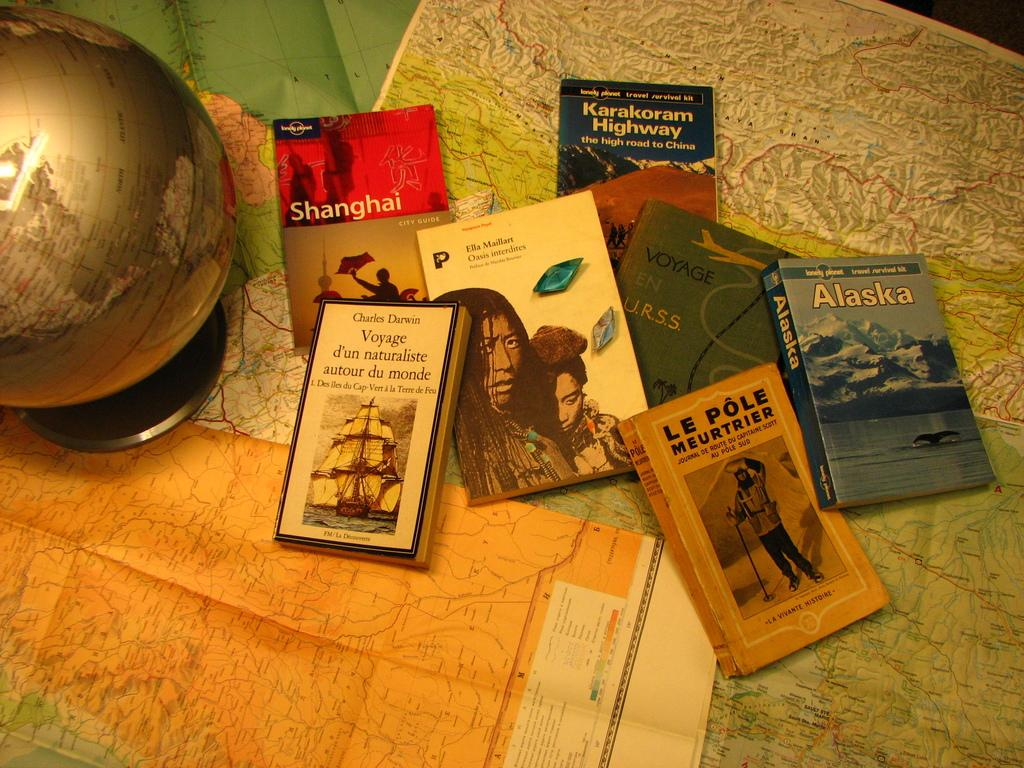Provide a one-sentence caption for the provided image. A pile of books, including two with Alaska and Shanghai in the titles, are scattered on the table. 